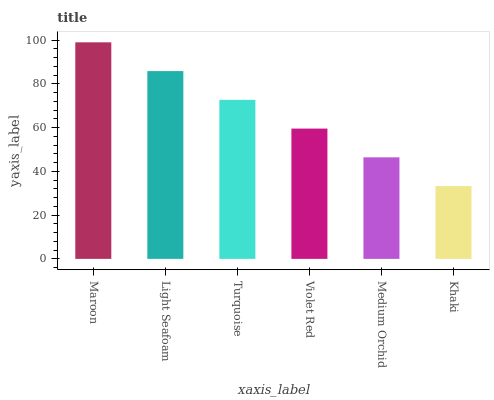Is Light Seafoam the minimum?
Answer yes or no. No. Is Light Seafoam the maximum?
Answer yes or no. No. Is Maroon greater than Light Seafoam?
Answer yes or no. Yes. Is Light Seafoam less than Maroon?
Answer yes or no. Yes. Is Light Seafoam greater than Maroon?
Answer yes or no. No. Is Maroon less than Light Seafoam?
Answer yes or no. No. Is Turquoise the high median?
Answer yes or no. Yes. Is Violet Red the low median?
Answer yes or no. Yes. Is Violet Red the high median?
Answer yes or no. No. Is Khaki the low median?
Answer yes or no. No. 